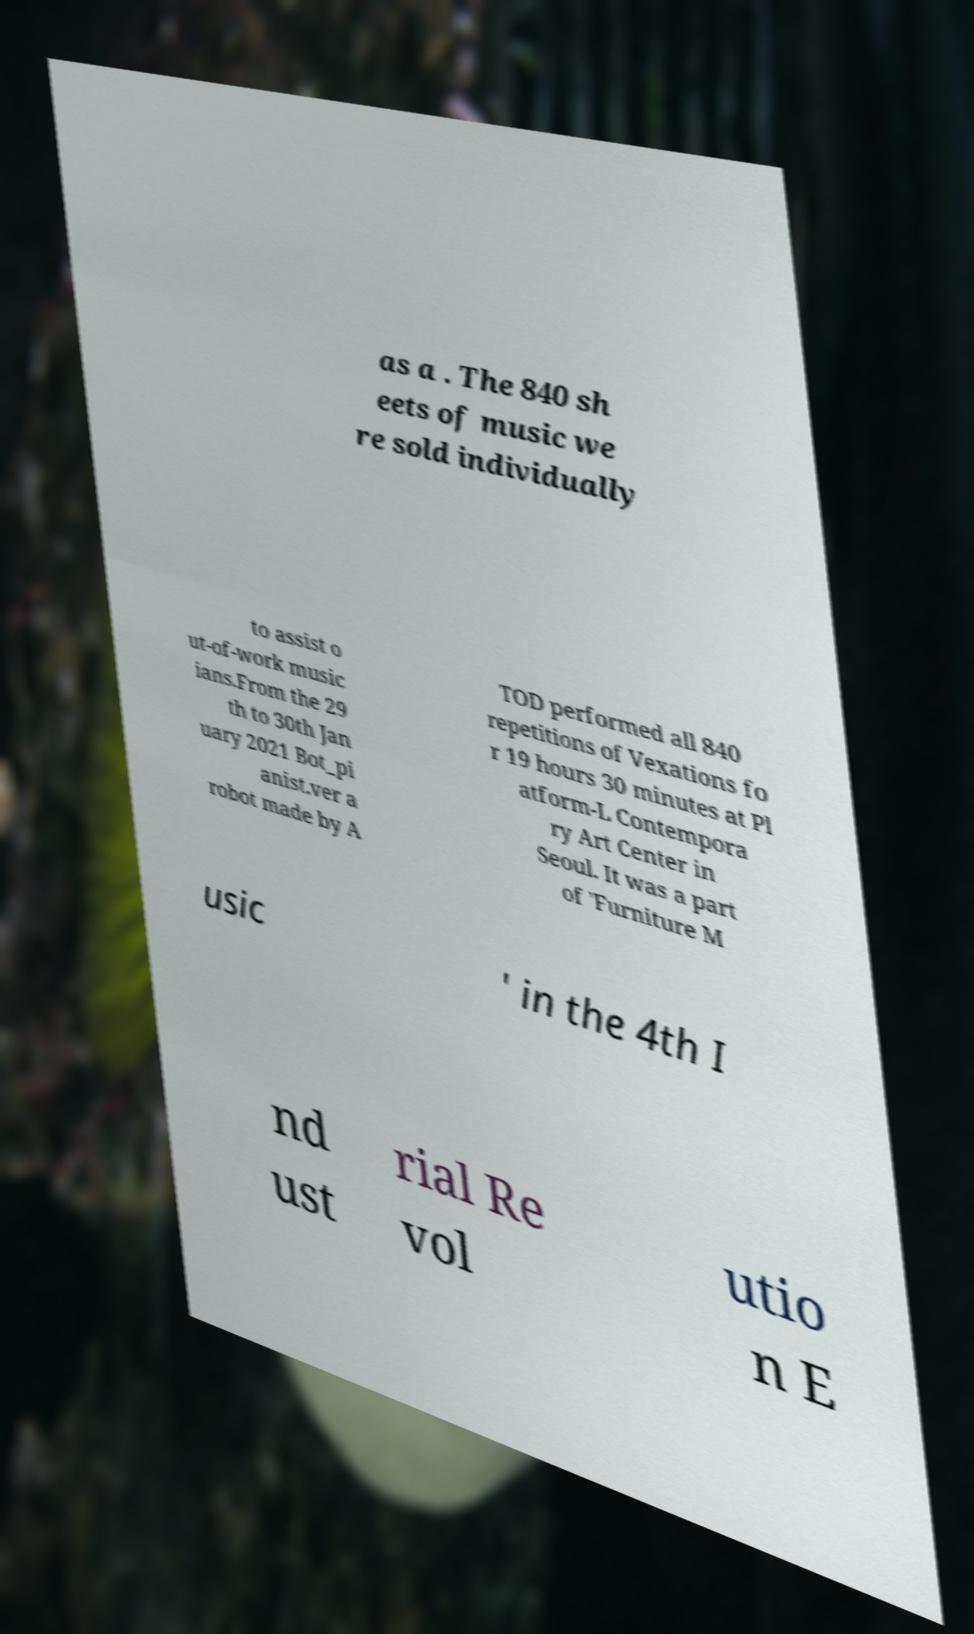For documentation purposes, I need the text within this image transcribed. Could you provide that? as a . The 840 sh eets of music we re sold individually to assist o ut-of-work music ians.From the 29 th to 30th Jan uary 2021 Bot_pi anist.ver a robot made by A TOD performed all 840 repetitions of Vexations fo r 19 hours 30 minutes at Pl atform-L Contempora ry Art Center in Seoul. It was a part of 'Furniture M usic ' in the 4th I nd ust rial Re vol utio n E 